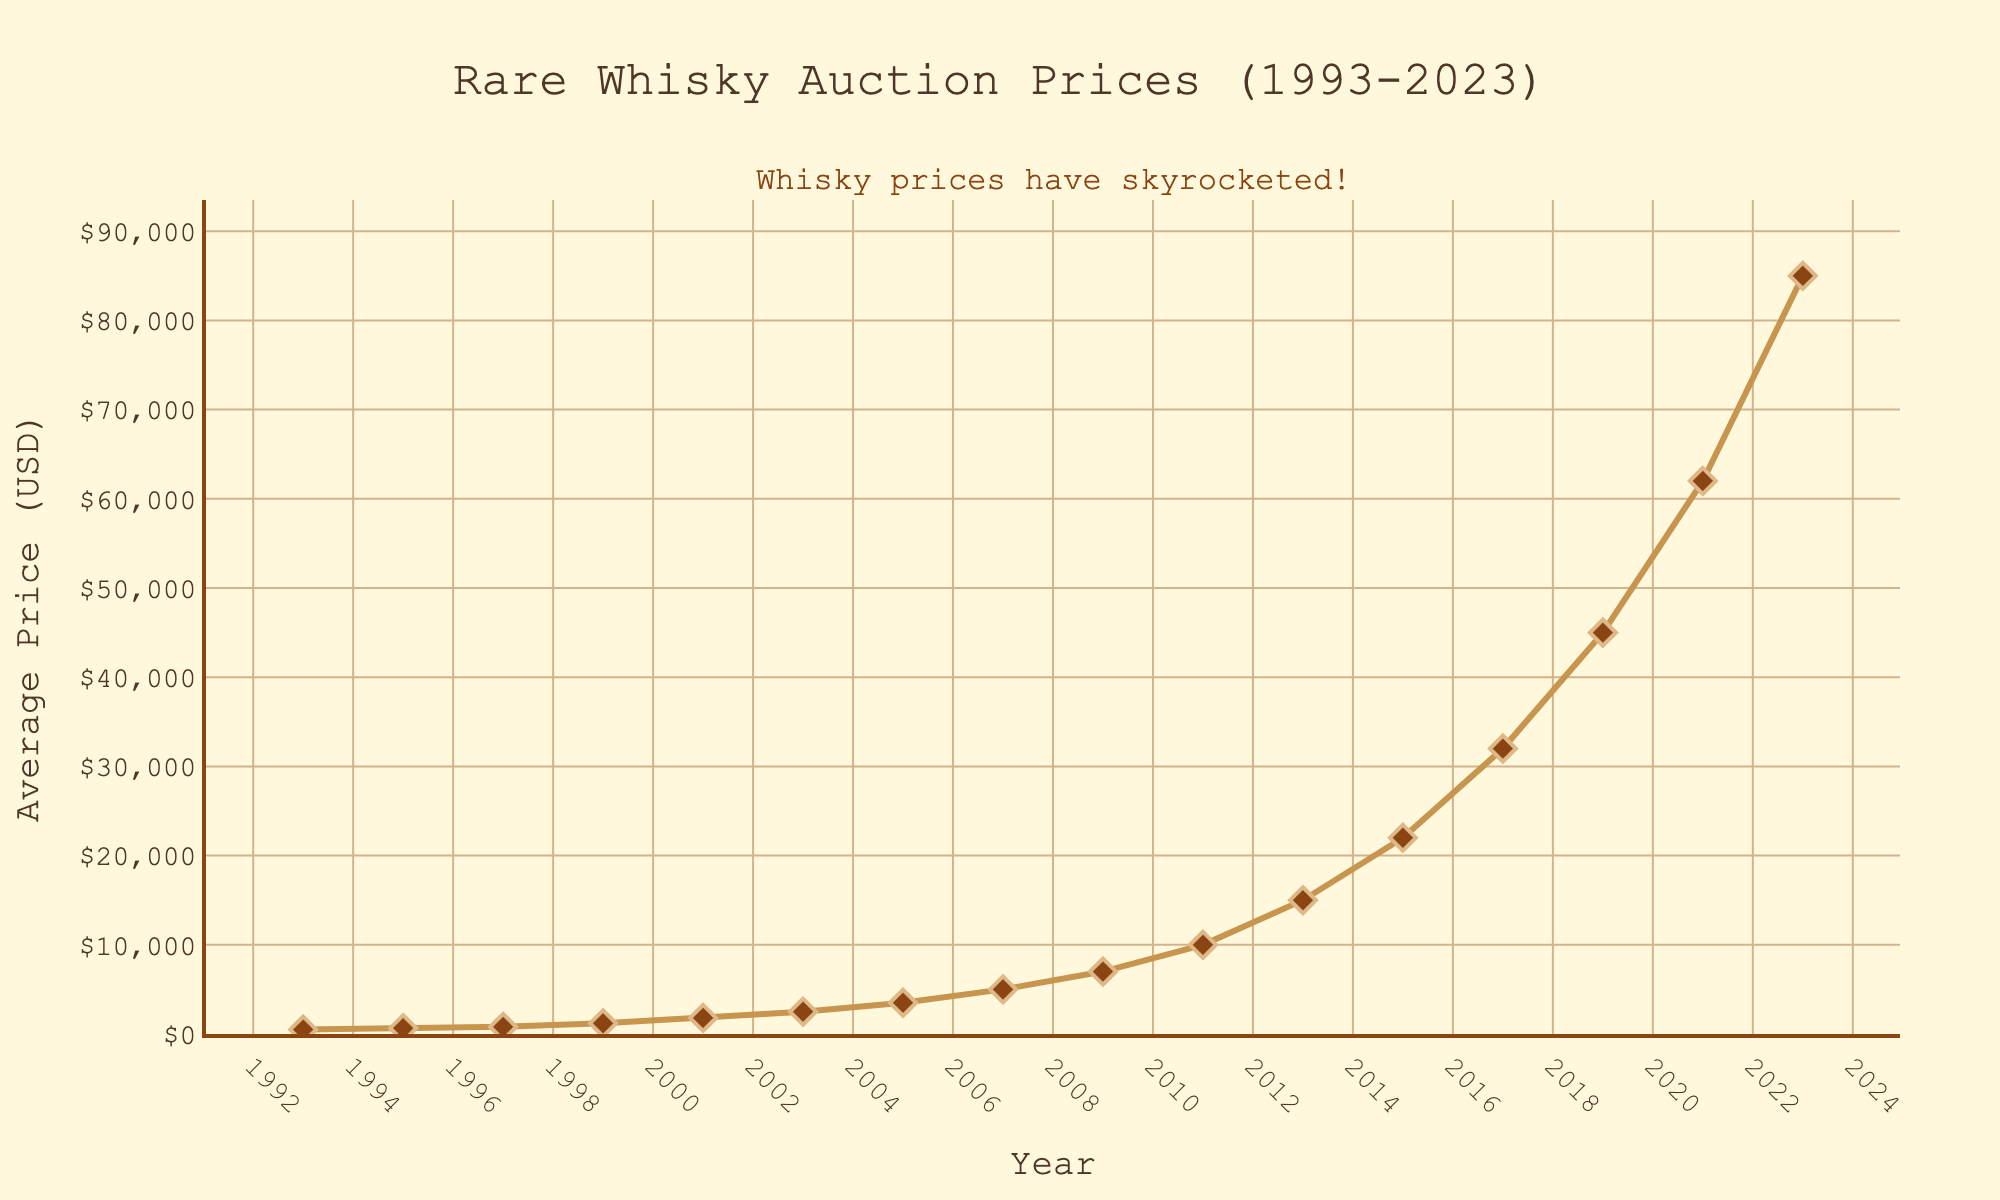What's the highest price reached for rare whiskies during these auctions? By looking at the figure, the highest data point on the y-axis corresponds to the year 2023. The y-axis value at this point is $85,000, thus the highest price reached is $85,000.
Answer: $85,000 In which year did the average price first exceed $10,000? By examining the data points on the plot, the price first exceeds $10,000 in the year 2011, where the average price is $10,000.
Answer: 2011 How much did the average price increase from 2011 to 2013? Look at the prices in 2011 ($10,000) and 2013 ($15,000). The increase is calculated by subtracting 10,000 from 15,000, resulting in an increase of $5,000.
Answer: $5,000 What is the average price of whiskies in the first 10 years of the data (1993 to 2003)? Prices from 1993 to 2003 are 500, 650, 800, 1200, 1800, and 2500. Sum these values (500 + 650 + 800 + 1200 + 1800 + 2500) to get 7450, and then divide by the number of years (6). The average is 7450/6 ≈ $1241.67.
Answer: ≈ $1241.67 Which year experienced the largest single-year increase in average price? Observe the changes year by year. The largest jump looks to be from 2019 ($45,000) to 2021 ($62,000). Calculate the increase as $62,000 - $45,000 = $17,000.
Answer: 2021 What is the price difference between 2009 and 1993? The price in 1993 was $500, and in 2009 it was $7,000. The difference is $7,000 - $500 = $6,500.
Answer: $6,500 Between which pair of consecutive years did the average price first double? Look for a pair where the second year's price is at least twice the first. From 1997 ($800) to 1999 ($1200) isn't a double. But from 1997 ($800) to 2001 ($1800), the price more than doubles.
Answer: 1997 and 2001 How does the price trend from 1993 to 2023 generally look? By observing the line chart from 1993 to 2023, the line shows a consistent upward trend, indicating increasing prices over time.
Answer: Increasing What is the difference in prices between the highest and lowest recorded years? The highest price is $85,000 (2023) and the lowest is $500 (1993). The difference is $85,000 - $500 = $84,500.
Answer: $84,500 What is the average annual growth in price between 1993 and 2023? Calculate the initial and final prices: $500 in 1993 and $85,000 in 2023. The increase is $85,000 - $500 = $84,500 over 30 years. The average annual growth is $84,500 / 30 ≈ $2,816.67 per year.
Answer: ≈ $2,816.67 per year 